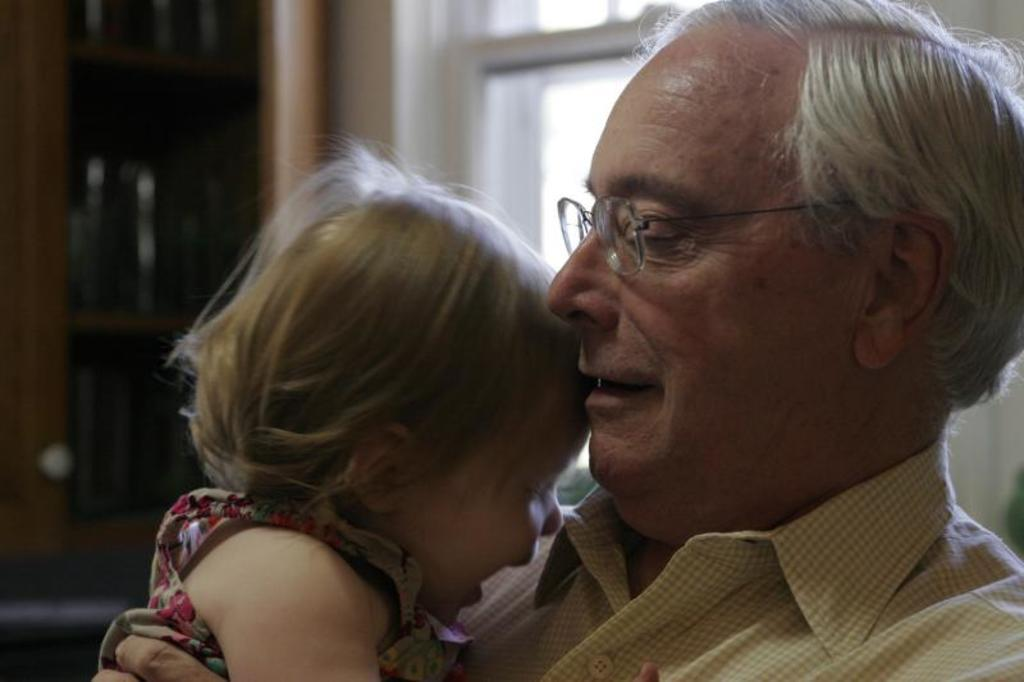Who is the main subject in the image? There is an old man in the image. What is the old man doing in the image? The old man is carrying a baby. What type of paper is the old man using to say good-bye to the baby in the image? There is no paper or indication of saying good-bye in the image; the old man is simply carrying a baby. 